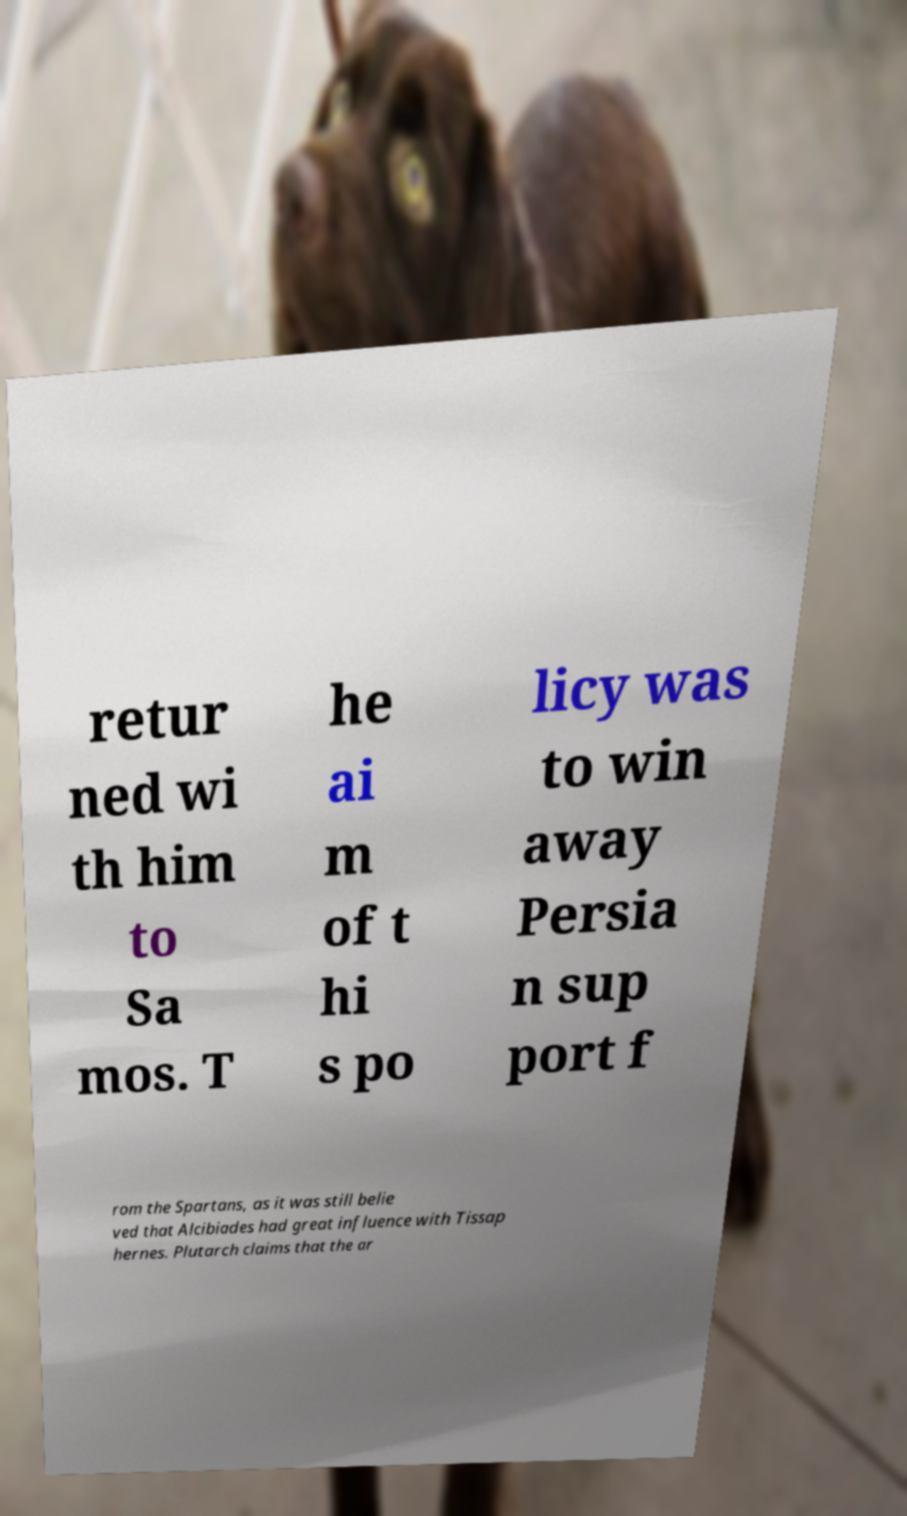I need the written content from this picture converted into text. Can you do that? retur ned wi th him to Sa mos. T he ai m of t hi s po licy was to win away Persia n sup port f rom the Spartans, as it was still belie ved that Alcibiades had great influence with Tissap hernes. Plutarch claims that the ar 